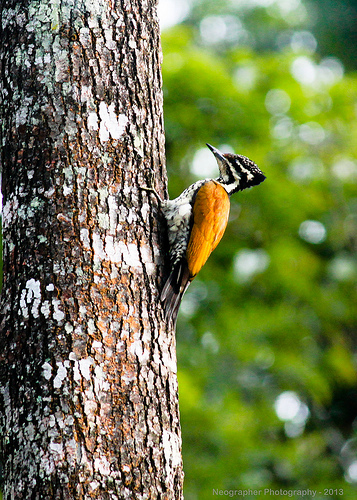Please provide the bounding box coordinate of the region this sentence describes: the leg of a bird. The region containing the bird's leg is accurately covered by the bounding box coordinates [0.44, 0.37, 0.47, 0.42], capturing the lower limb attached to a branch. 